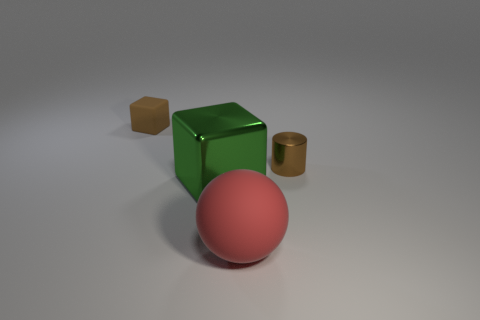What number of other objects are the same color as the tiny metallic object?
Your answer should be compact. 1. Is the number of green things in front of the large red rubber object less than the number of big balls?
Offer a terse response. Yes. What number of rubber things are there?
Keep it short and to the point. 2. How many green blocks have the same material as the ball?
Your answer should be compact. 0. How many objects are matte objects that are behind the big red ball or tiny things?
Keep it short and to the point. 2. Are there fewer tiny metal things that are on the left side of the rubber block than brown objects to the left of the large red rubber sphere?
Your answer should be very brief. Yes. There is a brown matte block; are there any green metal things behind it?
Your answer should be compact. No. What number of things are rubber objects on the left side of the big green block or blocks that are to the left of the green thing?
Make the answer very short. 1. What number of rubber balls have the same color as the rubber cube?
Offer a terse response. 0. There is a shiny object that is the same shape as the brown rubber object; what color is it?
Your response must be concise. Green. 